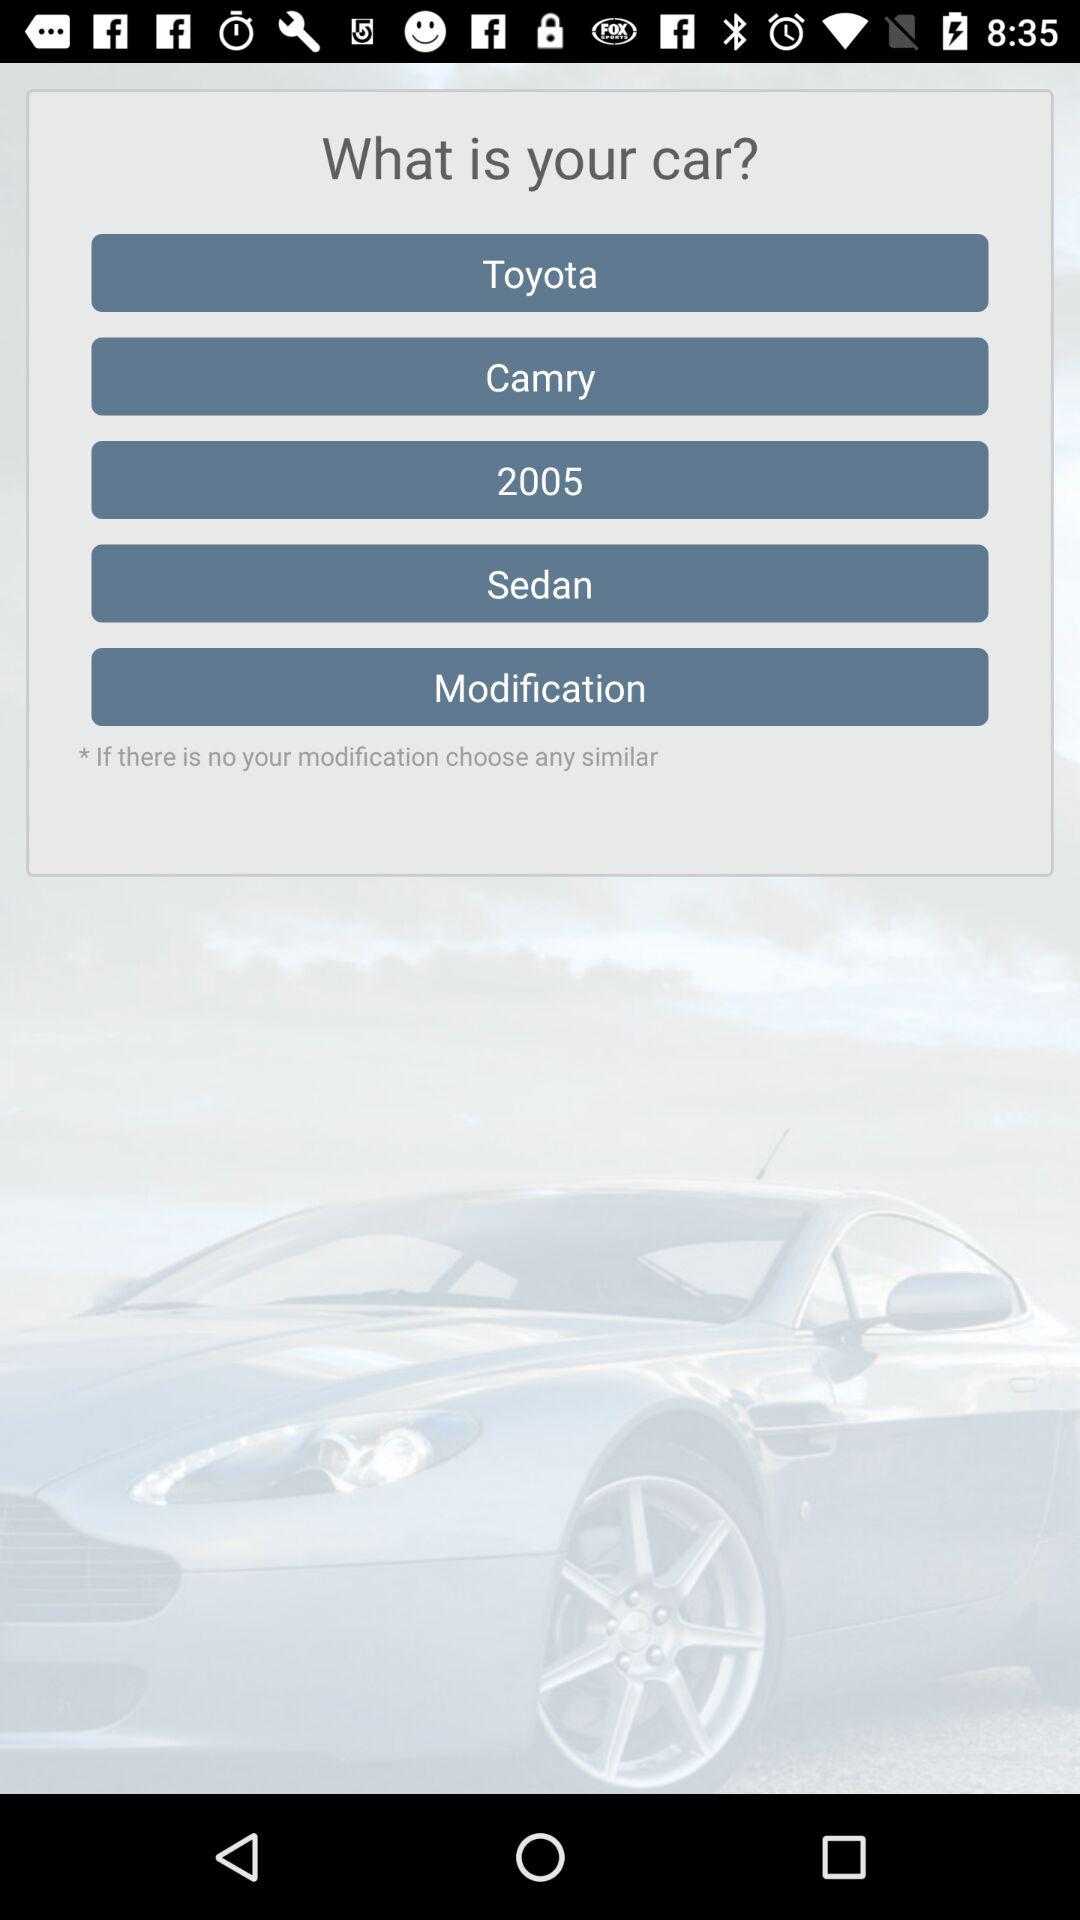What is the model name? The model name is "Camry". 